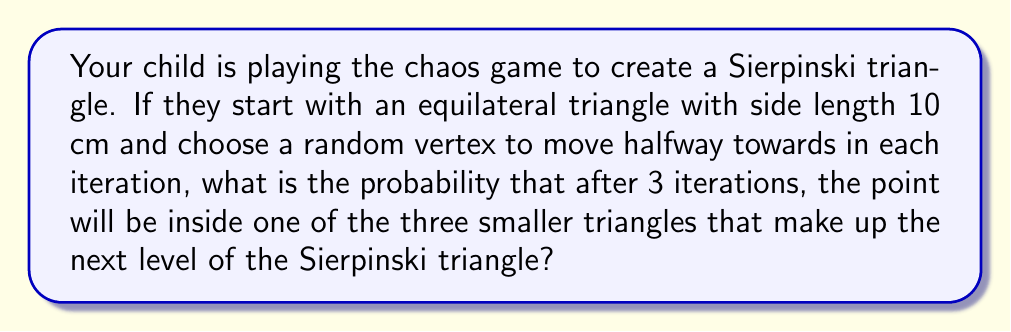Can you solve this math problem? Let's approach this step-by-step:

1) In the chaos game for the Sierpinski triangle, we start with an equilateral triangle and follow these steps:
   - Choose a random starting point
   - Randomly select one of the three vertices
   - Move halfway from the current position towards the chosen vertex
   - Repeat from step 2

2) After the first iteration, the point will always be inside one of the three smaller triangles that make up the next level of the Sierpinski triangle.

3) For the second iteration:
   - If we choose the vertex that corresponds to the small triangle we're in, we stay in that triangle.
   - If we choose either of the other two vertices, we move to one of the other two small triangles.
   - The probability of staying in the same triangle is $\frac{1}{3}$, and the probability of moving to a different triangle is $\frac{2}{3}$.

4) For the third iteration, we again have a $\frac{1}{3}$ chance of staying in our current triangle and a $\frac{2}{3}$ chance of moving to one of the other two triangles.

5) To be in one of the three smaller triangles after 3 iterations, we need to either:
   a) Stay in the same triangle all 3 times: $(\frac{1}{3})^3$
   b) Move to a different triangle on the 2nd iteration and stay there: $\frac{2}{3} \cdot \frac{1}{3}$
   c) Stay in the same triangle for 2 iterations and move on the 3rd: $\frac{1}{3} \cdot \frac{1}{3} \cdot \frac{2}{3}$
   d) Move to a different triangle on the 2nd iteration and move again on the 3rd: $\frac{2}{3} \cdot \frac{2}{3}$

6) The total probability is the sum of these:

   $$P = (\frac{1}{3})^3 + \frac{2}{3} \cdot \frac{1}{3} + \frac{1}{3} \cdot \frac{1}{3} \cdot \frac{2}{3} + \frac{2}{3} \cdot \frac{2}{3}$$

7) Simplifying:

   $$P = \frac{1}{27} + \frac{2}{9} + \frac{2}{27} + \frac{4}{9} = \frac{1 + 6 + 2 + 12}{27} = \frac{21}{27} = \frac{7}{9}$$
Answer: $\frac{7}{9}$ 